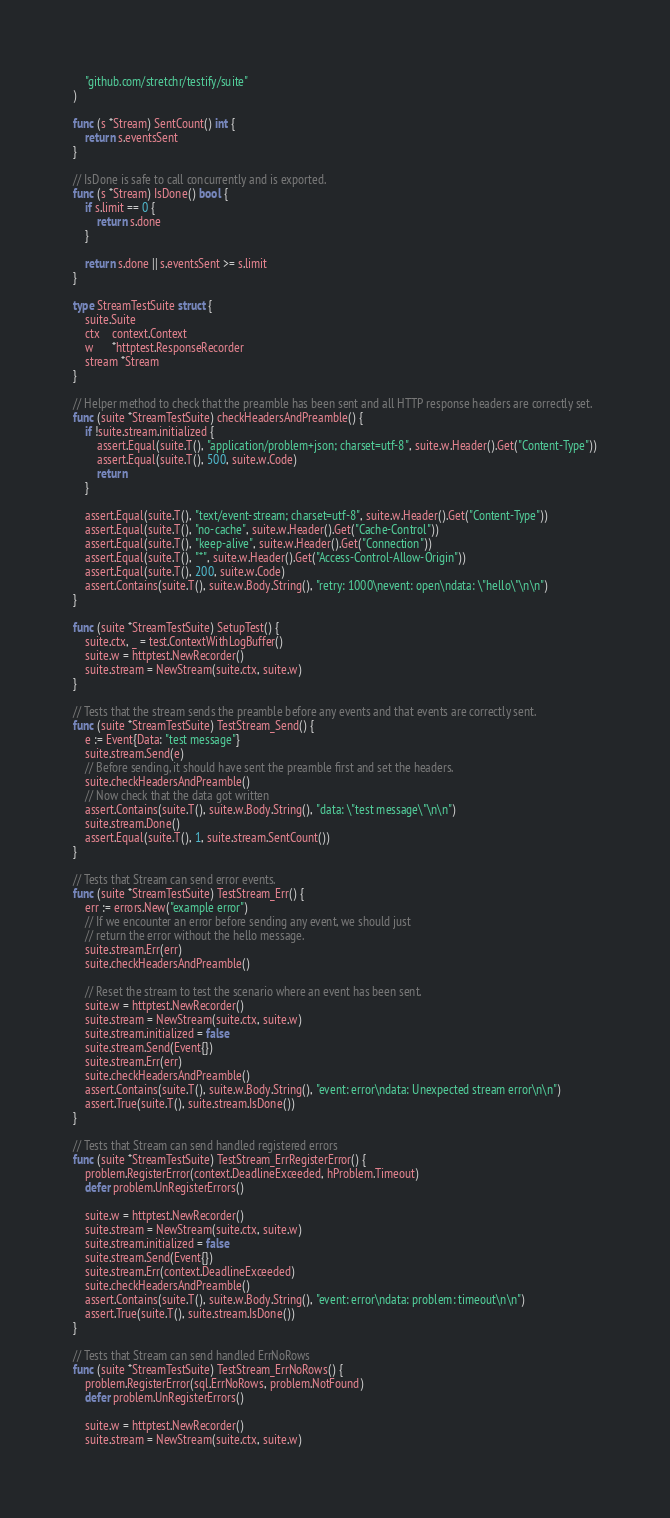<code> <loc_0><loc_0><loc_500><loc_500><_Go_>	"github.com/stretchr/testify/suite"
)

func (s *Stream) SentCount() int {
	return s.eventsSent
}

// IsDone is safe to call concurrently and is exported.
func (s *Stream) IsDone() bool {
	if s.limit == 0 {
		return s.done
	}

	return s.done || s.eventsSent >= s.limit
}

type StreamTestSuite struct {
	suite.Suite
	ctx    context.Context
	w      *httptest.ResponseRecorder
	stream *Stream
}

// Helper method to check that the preamble has been sent and all HTTP response headers are correctly set.
func (suite *StreamTestSuite) checkHeadersAndPreamble() {
	if !suite.stream.initialized {
		assert.Equal(suite.T(), "application/problem+json; charset=utf-8", suite.w.Header().Get("Content-Type"))
		assert.Equal(suite.T(), 500, suite.w.Code)
		return
	}

	assert.Equal(suite.T(), "text/event-stream; charset=utf-8", suite.w.Header().Get("Content-Type"))
	assert.Equal(suite.T(), "no-cache", suite.w.Header().Get("Cache-Control"))
	assert.Equal(suite.T(), "keep-alive", suite.w.Header().Get("Connection"))
	assert.Equal(suite.T(), "*", suite.w.Header().Get("Access-Control-Allow-Origin"))
	assert.Equal(suite.T(), 200, suite.w.Code)
	assert.Contains(suite.T(), suite.w.Body.String(), "retry: 1000\nevent: open\ndata: \"hello\"\n\n")
}

func (suite *StreamTestSuite) SetupTest() {
	suite.ctx, _ = test.ContextWithLogBuffer()
	suite.w = httptest.NewRecorder()
	suite.stream = NewStream(suite.ctx, suite.w)
}

// Tests that the stream sends the preamble before any events and that events are correctly sent.
func (suite *StreamTestSuite) TestStream_Send() {
	e := Event{Data: "test message"}
	suite.stream.Send(e)
	// Before sending, it should have sent the preamble first and set the headers.
	suite.checkHeadersAndPreamble()
	// Now check that the data got written
	assert.Contains(suite.T(), suite.w.Body.String(), "data: \"test message\"\n\n")
	suite.stream.Done()
	assert.Equal(suite.T(), 1, suite.stream.SentCount())
}

// Tests that Stream can send error events.
func (suite *StreamTestSuite) TestStream_Err() {
	err := errors.New("example error")
	// If we encounter an error before sending any event, we should just
	// return the error without the hello message.
	suite.stream.Err(err)
	suite.checkHeadersAndPreamble()

	// Reset the stream to test the scenario where an event has been sent.
	suite.w = httptest.NewRecorder()
	suite.stream = NewStream(suite.ctx, suite.w)
	suite.stream.initialized = false
	suite.stream.Send(Event{})
	suite.stream.Err(err)
	suite.checkHeadersAndPreamble()
	assert.Contains(suite.T(), suite.w.Body.String(), "event: error\ndata: Unexpected stream error\n\n")
	assert.True(suite.T(), suite.stream.IsDone())
}

// Tests that Stream can send handled registered errors
func (suite *StreamTestSuite) TestStream_ErrRegisterError() {
	problem.RegisterError(context.DeadlineExceeded, hProblem.Timeout)
	defer problem.UnRegisterErrors()

	suite.w = httptest.NewRecorder()
	suite.stream = NewStream(suite.ctx, suite.w)
	suite.stream.initialized = false
	suite.stream.Send(Event{})
	suite.stream.Err(context.DeadlineExceeded)
	suite.checkHeadersAndPreamble()
	assert.Contains(suite.T(), suite.w.Body.String(), "event: error\ndata: problem: timeout\n\n")
	assert.True(suite.T(), suite.stream.IsDone())
}

// Tests that Stream can send handled ErrNoRows
func (suite *StreamTestSuite) TestStream_ErrNoRows() {
	problem.RegisterError(sql.ErrNoRows, problem.NotFound)
	defer problem.UnRegisterErrors()

	suite.w = httptest.NewRecorder()
	suite.stream = NewStream(suite.ctx, suite.w)</code> 